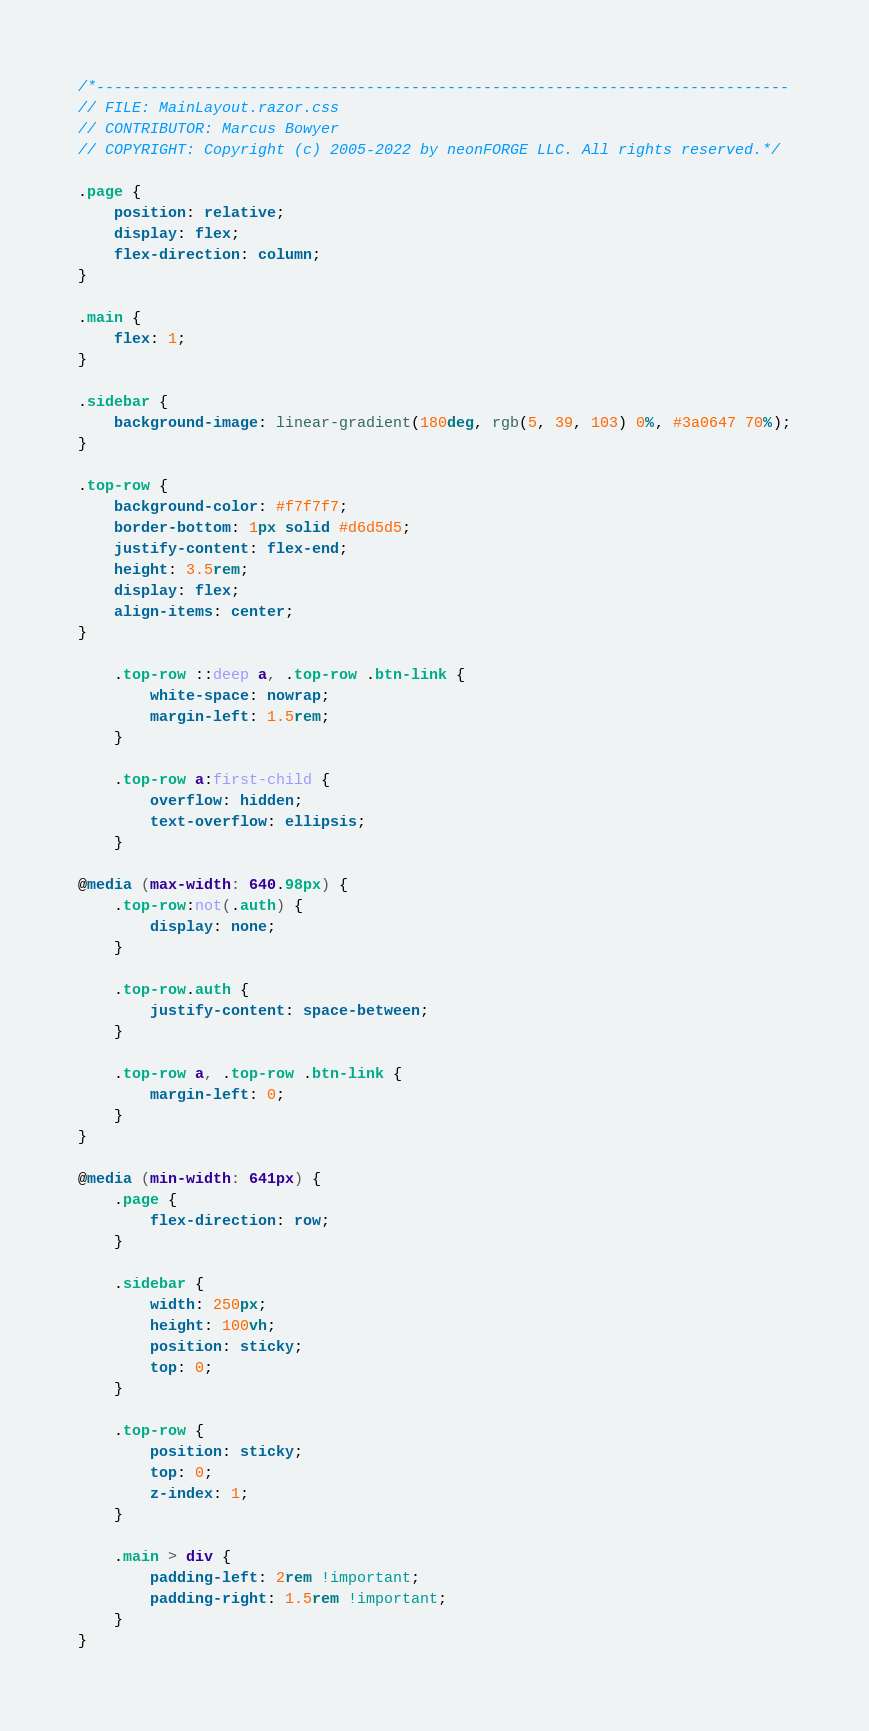Convert code to text. <code><loc_0><loc_0><loc_500><loc_500><_CSS_>/*-----------------------------------------------------------------------------
// FILE: MainLayout.razor.css
// CONTRIBUTOR: Marcus Bowyer
// COPYRIGHT: Copyright (c) 2005-2022 by neonFORGE LLC. All rights reserved.*/

.page {
    position: relative;
    display: flex;
    flex-direction: column;
}

.main {
    flex: 1;
}

.sidebar {
    background-image: linear-gradient(180deg, rgb(5, 39, 103) 0%, #3a0647 70%);
}

.top-row {
    background-color: #f7f7f7;
    border-bottom: 1px solid #d6d5d5;
    justify-content: flex-end;
    height: 3.5rem;
    display: flex;
    align-items: center;
}

    .top-row ::deep a, .top-row .btn-link {
        white-space: nowrap;
        margin-left: 1.5rem;
    }

    .top-row a:first-child {
        overflow: hidden;
        text-overflow: ellipsis;
    }

@media (max-width: 640.98px) {
    .top-row:not(.auth) {
        display: none;
    }

    .top-row.auth {
        justify-content: space-between;
    }

    .top-row a, .top-row .btn-link {
        margin-left: 0;
    }
}

@media (min-width: 641px) {
    .page {
        flex-direction: row;
    }

    .sidebar {
        width: 250px;
        height: 100vh;
        position: sticky;
        top: 0;
    }

    .top-row {
        position: sticky;
        top: 0;
        z-index: 1;
    }

    .main > div {
        padding-left: 2rem !important;
        padding-right: 1.5rem !important;
    }
}
</code> 